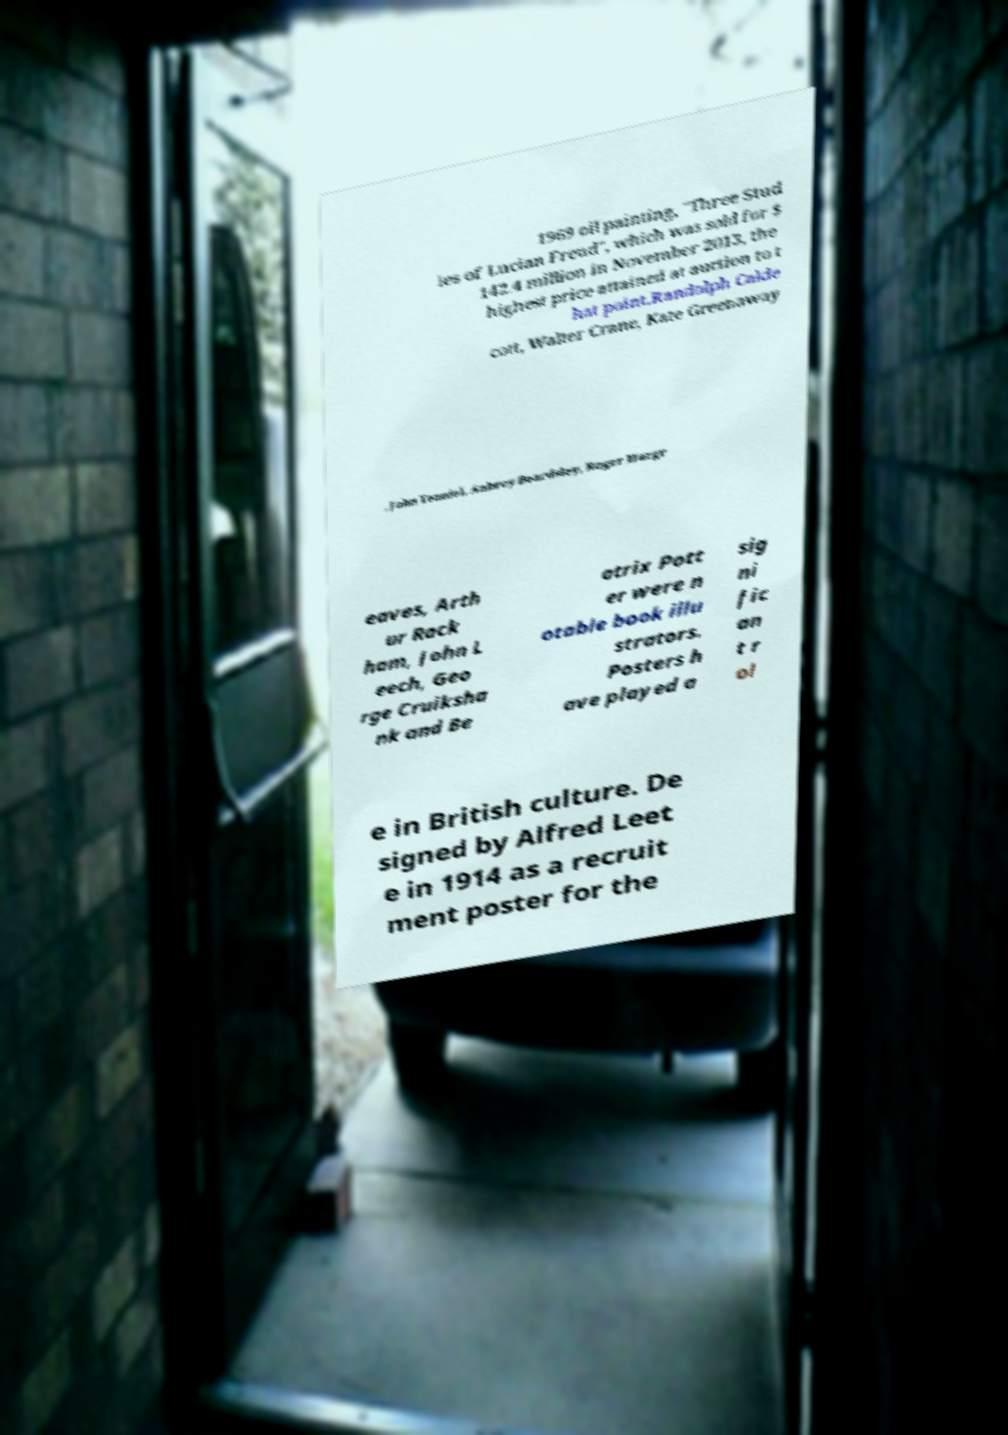There's text embedded in this image that I need extracted. Can you transcribe it verbatim? 1969 oil painting, "Three Stud ies of Lucian Freud", which was sold for $ 142.4 million in November 2013, the highest price attained at auction to t hat point.Randolph Calde cott, Walter Crane, Kate Greenaway , John Tenniel, Aubrey Beardsley, Roger Hargr eaves, Arth ur Rack ham, John L eech, Geo rge Cruiksha nk and Be atrix Pott er were n otable book illu strators. Posters h ave played a sig ni fic an t r ol e in British culture. De signed by Alfred Leet e in 1914 as a recruit ment poster for the 